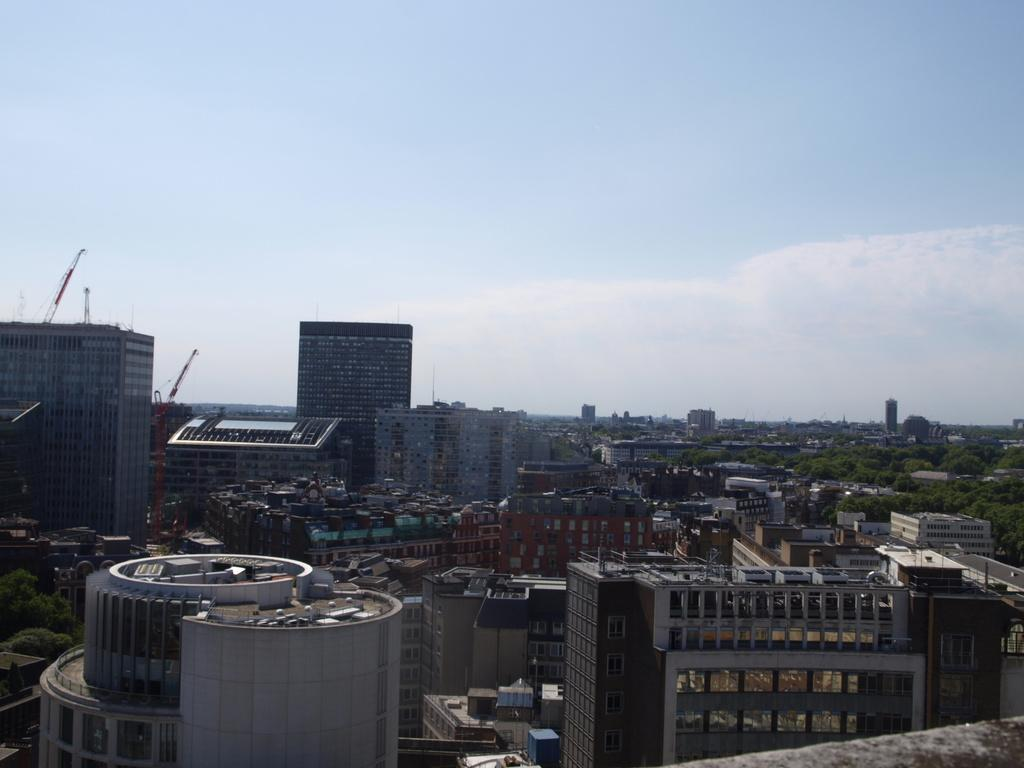What type of location is depicted in the image? The image is of a city. What structures can be seen in the city? There are buildings in the image. Are there any natural elements present in the city? Yes, there are trees in the image. What construction equipment can be seen in the image? There are cranes in the image. What is visible at the top of the image? The sky is visible at the top of the image, and there are clouds in the sky. Where is a wall located in the image? There is a wall at the bottom right of the image. What type of plants are growing on the border of the image? There are no plants growing on the border of the image, as the border refers to the edge of the image and not a physical border within the image. 